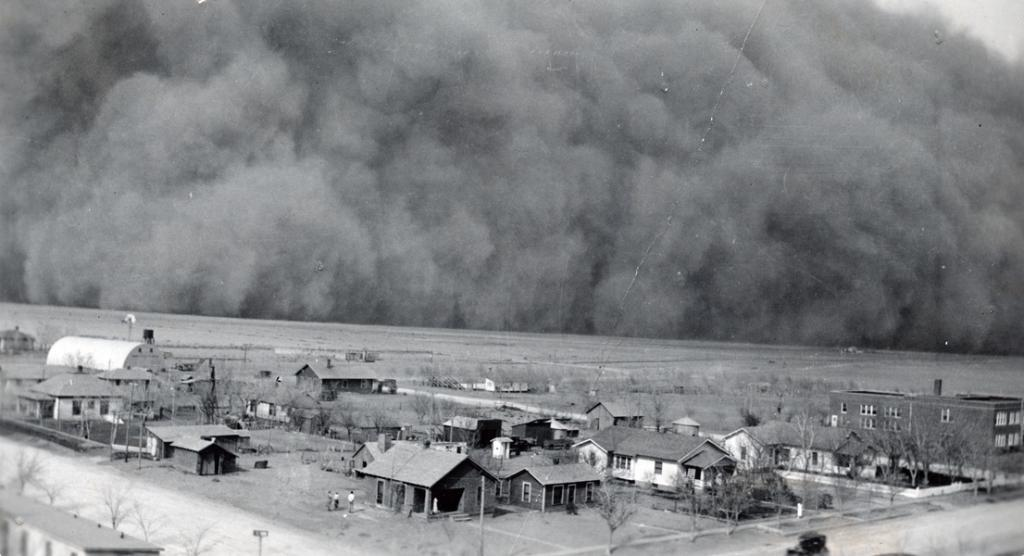What type of structures can be seen in the image? There are huts and buildings in the image. What other natural elements are present in the image? There are trees in the image. Are there any living beings visible in the image? Yes, there are people in the image. What can be observed in the air in the image? There is smoke visible in the image. What type of vein is visible in the image? There is no vein present in the image. How much sugar can be seen in the image? There is no sugar visible in the image. 